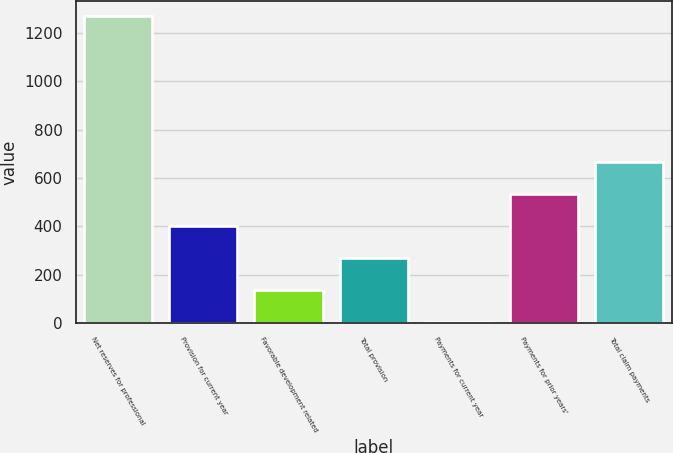Convert chart. <chart><loc_0><loc_0><loc_500><loc_500><bar_chart><fcel>Net reserves for professional<fcel>Provision for current year<fcel>Favorable development related<fcel>Total provision<fcel>Payments for current year<fcel>Payments for prior years'<fcel>Total claim payments<nl><fcel>1269<fcel>401.8<fcel>136.6<fcel>269.2<fcel>4<fcel>534.4<fcel>667<nl></chart> 